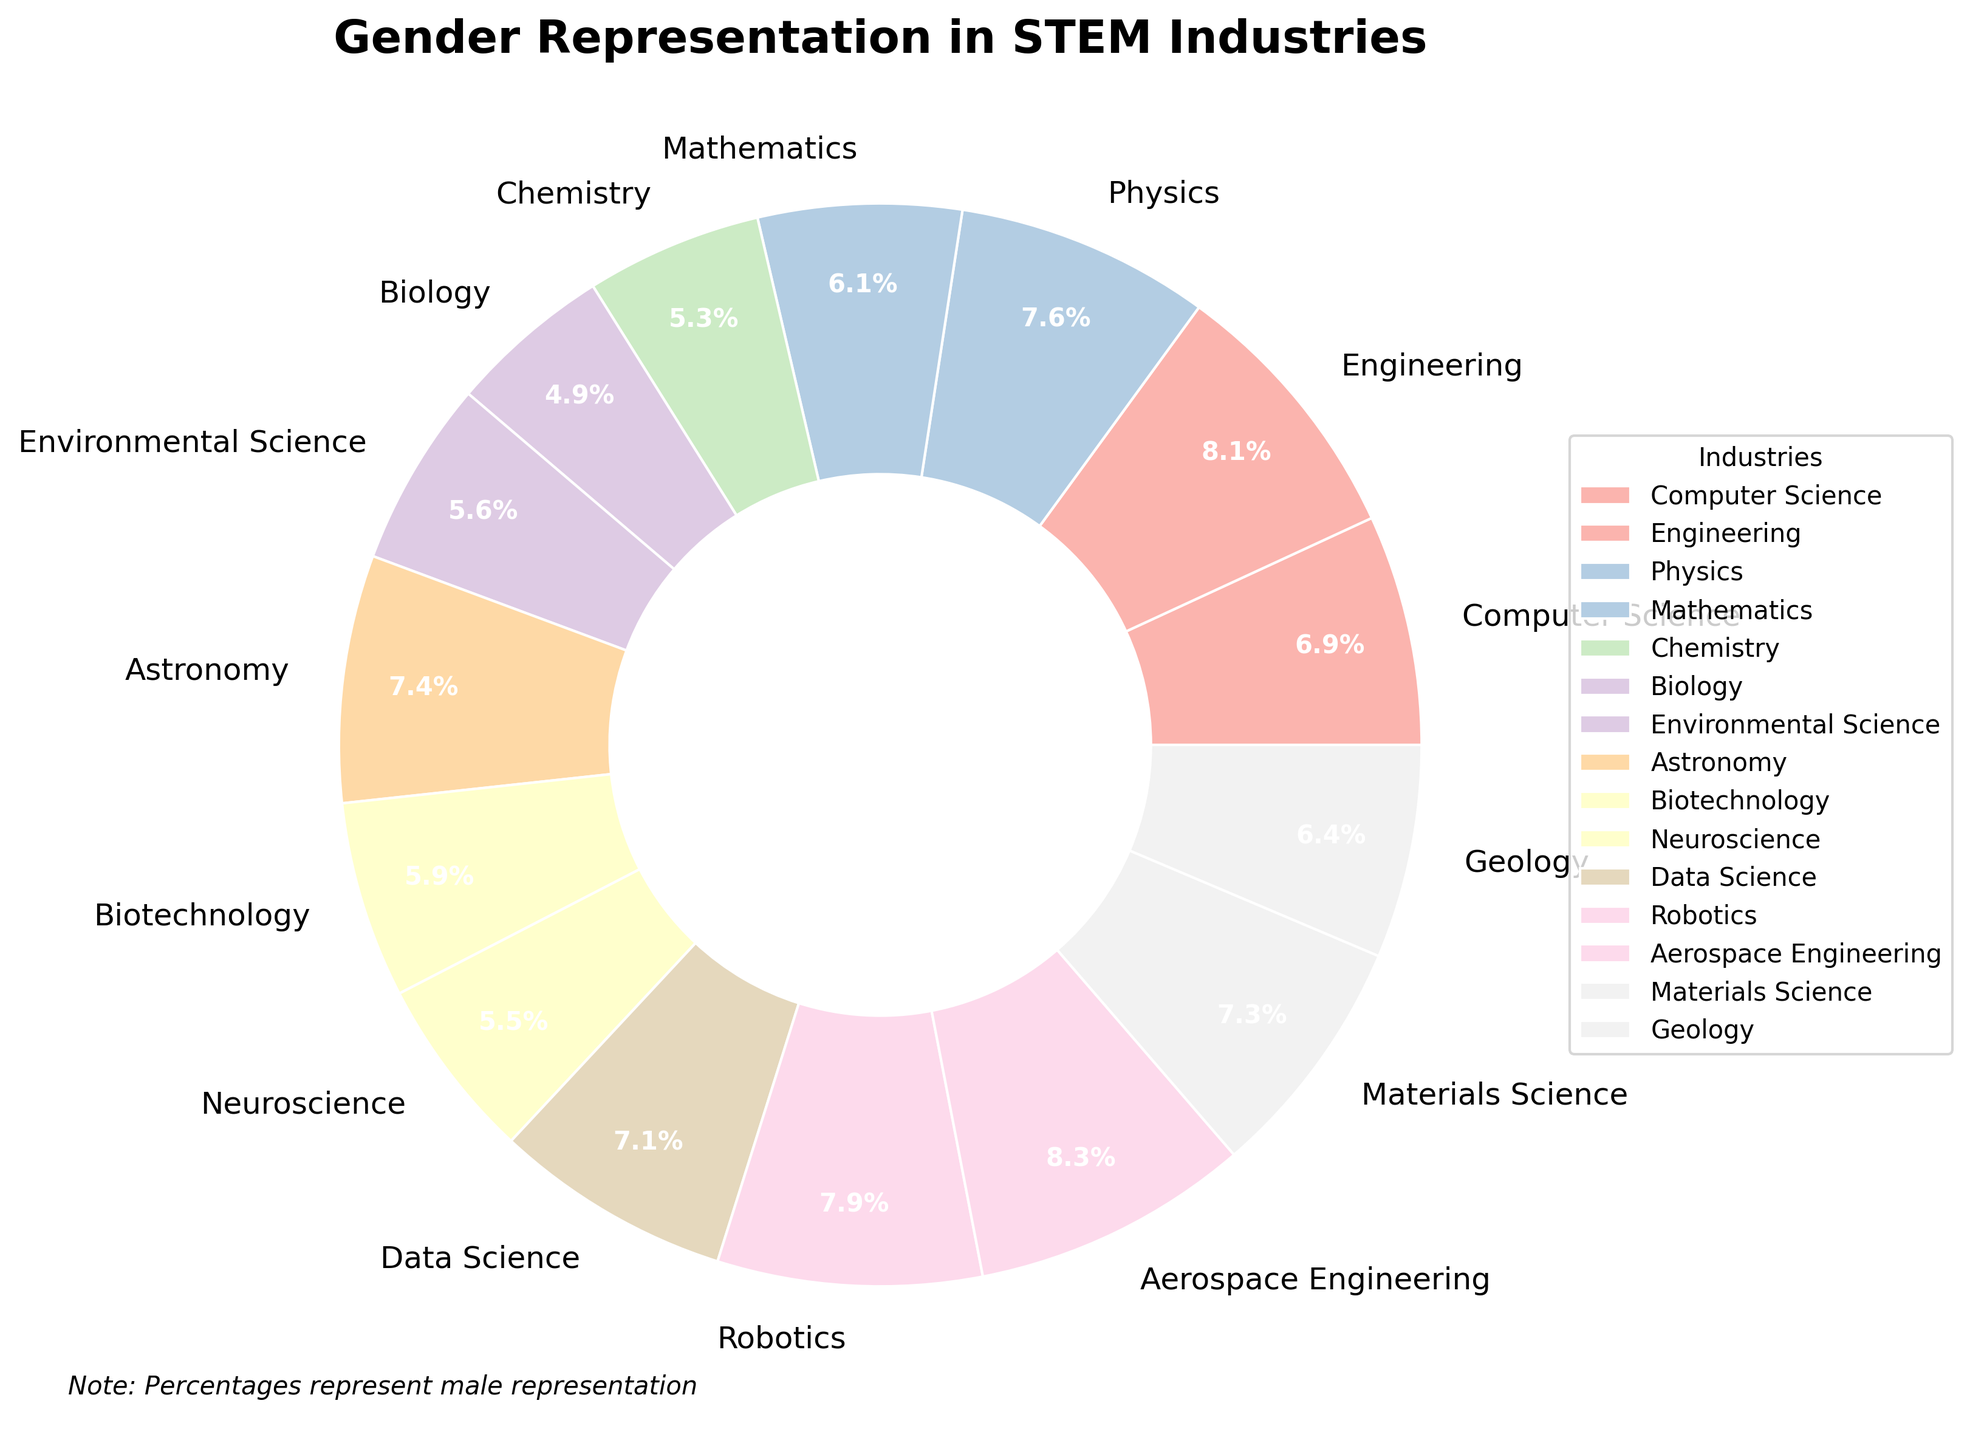Which industry has the highest percentage of gender representation? The pie chart shows various STEM industries with their respective percentages of gender representation. The highest percentage observed is 82%, which belongs to Aerospace Engineering.
Answer: Aerospace Engineering Which two industries have the closest percentages of gender representation? By examining the percentages on the pie chart, Biotechnology has 58% and Neuroscience has 54%. The difference between them is 4%, which is the smallest gap among the industries listed.
Answer: Biotechnology and Neuroscience What is the average percentage of gender representation across all listed industries? To find the average, sum all the percentages and divide by the number of industries. The percentages are: 68, 80, 75, 60, 52, 48, 55, 73, 58, 54, 70, 78, 82, 72, and 63. The total is 978. Dividing by 15 industries gives us 978 / 15 = 65.2.
Answer: 65.2% Which industry has the lowest gender representation percentage? The industry with the lowest percentage on the pie chart is Biology, which has 48%.
Answer: Biology How many industries have a gender representation percentage greater than or equal to 70%? Industries with percentages 70% or higher include: Computer Science (68%), Engineering (80%), Physics (75%), Mathematics (60%), Data Science (70%), Robotics (78%), Aerospace Engineering (82%), and Materials Science (72%). Count them to get 8 industries.
Answer: 8 Among Computer Science, Robotics, and Geology, which has the highest gender representation percentage? By comparing the percentages in the pie chart: Computer Science (68%), Robotics (78%), and Geology (63%), Robotics has the highest percentage.
Answer: Robotics What is the combined percentage of gender representation for Engineering and Data Science? Engineering has 80% and Data Science has 70%. Adding these together gives 80 + 70 = 150%.
Answer: 150% How much higher is the gender representation percentage in Chemistry compared to Biology? Chemistry has a percentage of 52%, and Biology has 48%. The difference is 52 - 48 = 4%.
Answer: 4% Which industry has the closest representation percentage to the average percentage calculated across all industries? From the average calculated earlier (65.2%), Geology has 63%, which is closest to 65.2%.
Answer: Geology 